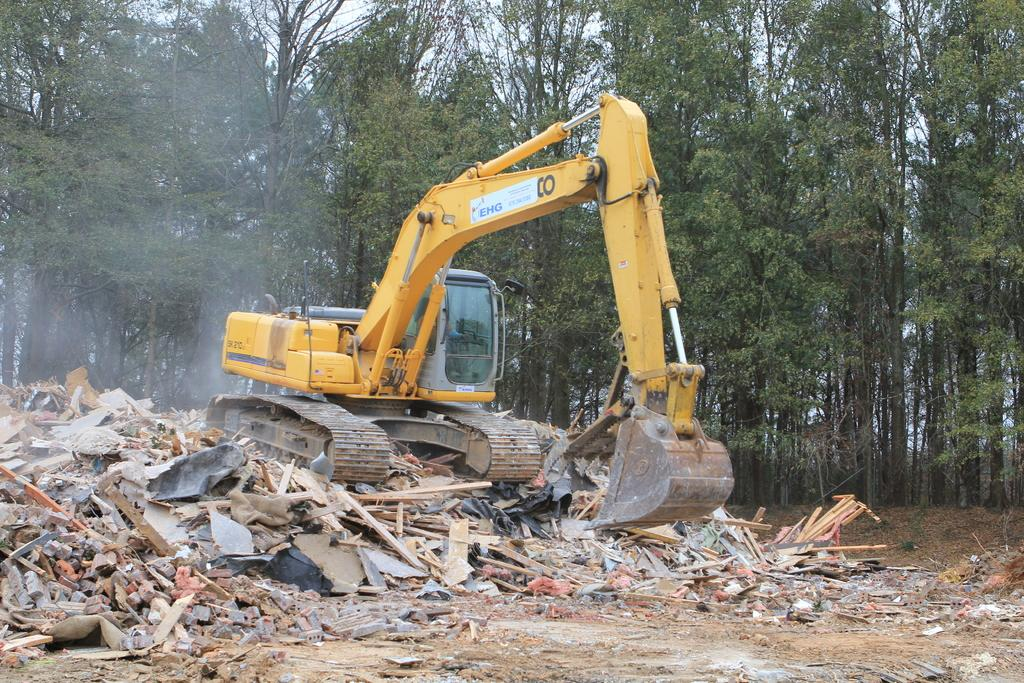What type of object is featured in the image? There is a pro cleaner in the image. What color is the pro cleaner? The pro cleaner is yellow. What type of vegetation can be seen in the image? There are green color trees in the image. How many beds are visible in the image? There are no beds present in the image; it features a yellow pro cleaner and green color trees. What type of shirt is the pro cleaner wearing in the image? The pro cleaner is an object and does not wear clothing, so there is no shirt present in the image. 